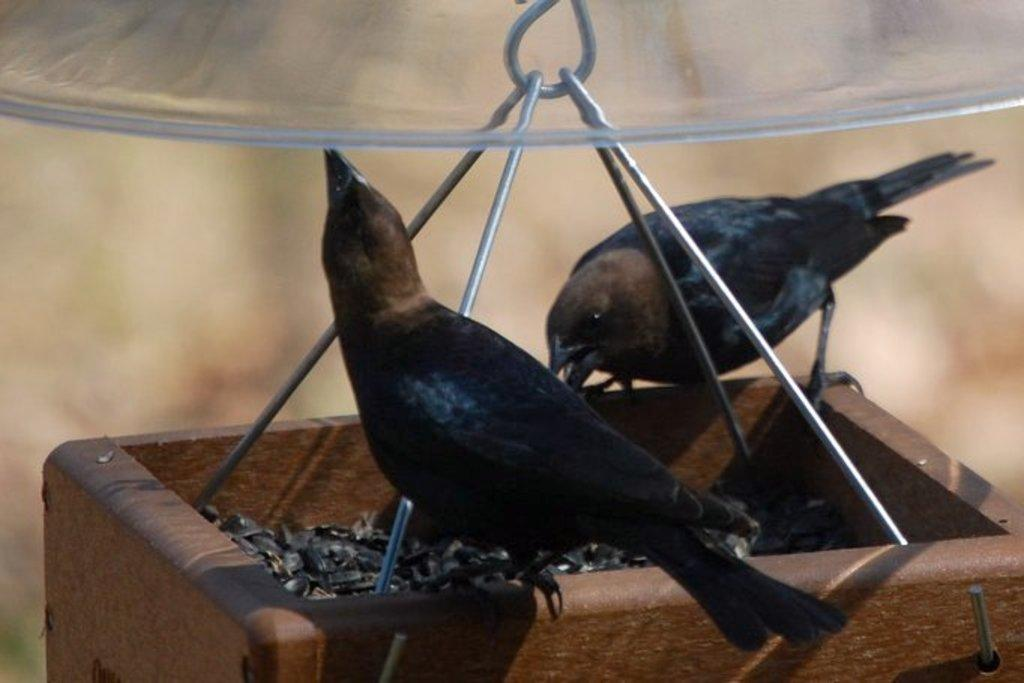How many birds are present in the image? There are two birds in the image. Where are the birds located? The birds are on a container. What type of material is used for the container's structure? The container has metal rods. What type of toe can be seen on the birds in the image? Birds do not have toes like mammals; they have claws or talons. However, the image does not show the birds' feet or claws, so it cannot be determined from the image. 